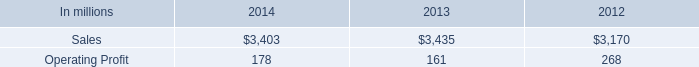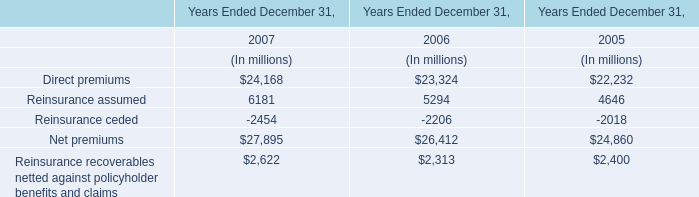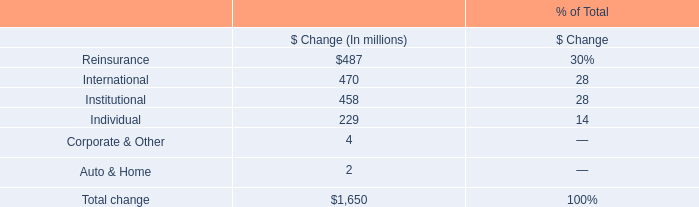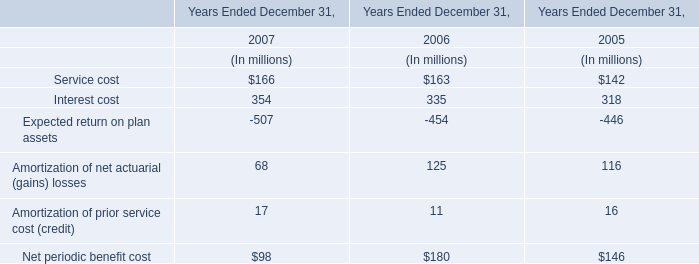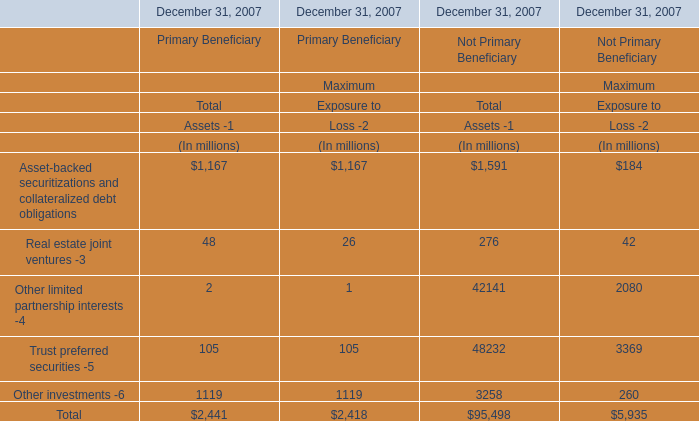What is the sum of Maximum Exposure to Loss -2 in the range of 1000 and 1500 in 2007? (in million) 
Computations: (1167 + 1119)
Answer: 2286.0. 